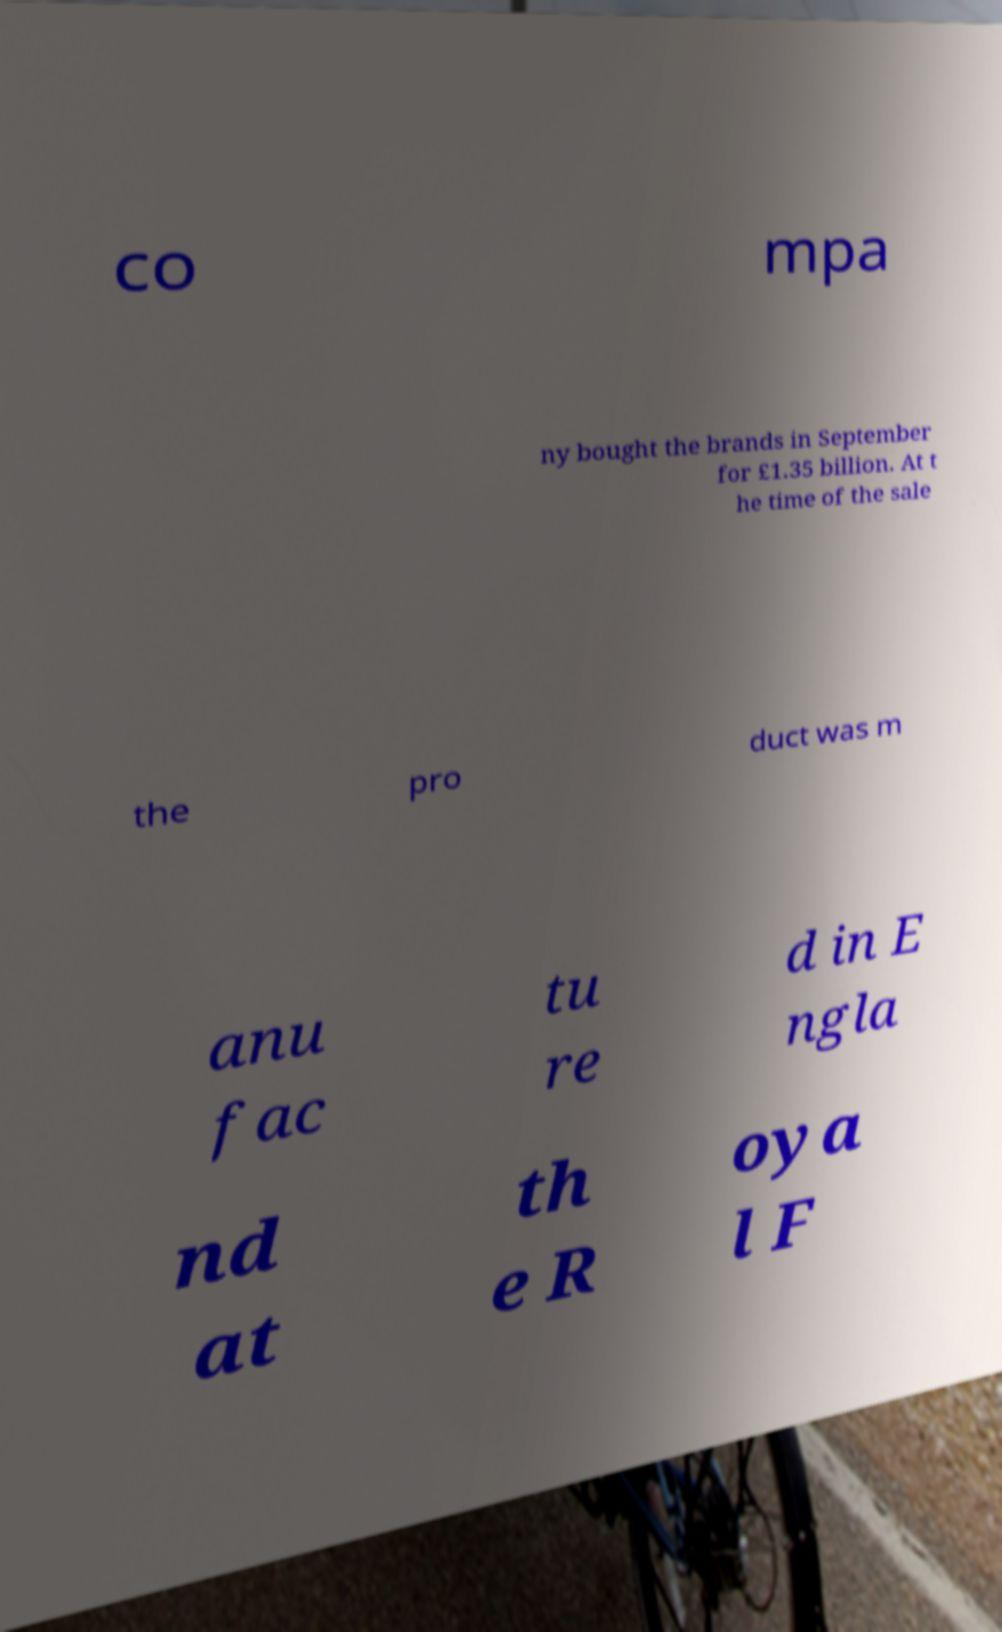I need the written content from this picture converted into text. Can you do that? co mpa ny bought the brands in September for £1.35 billion. At t he time of the sale the pro duct was m anu fac tu re d in E ngla nd at th e R oya l F 